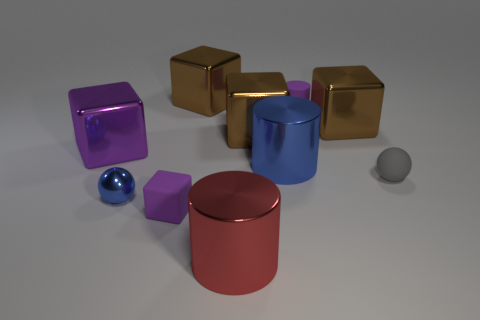The shiny object that is the same color as the tiny rubber block is what size?
Make the answer very short. Large. Do the purple thing that is behind the purple metallic block and the block in front of the large purple thing have the same size?
Offer a terse response. Yes. How many purple objects are both left of the red cylinder and on the right side of the blue shiny cylinder?
Make the answer very short. 0. What is the color of the small rubber thing that is the same shape as the large red metal object?
Your answer should be very brief. Purple. Are there fewer blue balls than tiny rubber things?
Offer a very short reply. Yes. There is a purple cylinder; is its size the same as the purple thing that is in front of the big purple metallic block?
Make the answer very short. Yes. What is the color of the metal object that is right of the small purple rubber object that is behind the small shiny ball?
Provide a succinct answer. Brown. How many things are either purple blocks in front of the small gray ball or purple rubber objects that are on the left side of the purple rubber cylinder?
Your response must be concise. 1. Do the blue shiny cylinder and the gray thing have the same size?
Your answer should be very brief. No. Is there any other thing that has the same size as the red object?
Provide a short and direct response. Yes. 